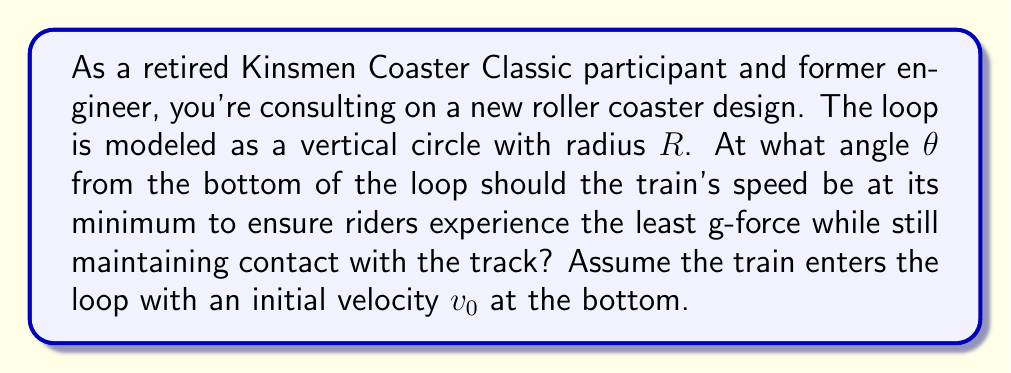Solve this math problem. Let's approach this step-by-step:

1) First, we need to understand the forces acting on the riders. At any point in the loop, there are two main forces:
   - Centripetal force: $F_c = \frac{mv^2}{R}$
   - Gravitational force: $mg$

2) For the riders to maintain contact with the track, the centripetal force must be greater than or equal to the component of gravity perpendicular to the track:

   $$\frac{mv^2}{R} \geq mg\cos\theta$$

3) The velocity at any point in the loop can be found using conservation of energy:

   $$\frac{1}{2}mv_0^2 = \frac{1}{2}mv^2 + mgR(1-\cos\theta)$$

   Solving for $v^2$:

   $$v^2 = v_0^2 - 2gR(1-\cos\theta)$$

4) Substituting this into the inequality from step 2:

   $$\frac{m(v_0^2 - 2gR(1-\cos\theta))}{R} \geq mg\cos\theta$$

5) Simplifying:

   $$\frac{v_0^2}{R} - \frac{2g(1-\cos\theta)}{1} \geq g\cos\theta$$

6) To minimize g-forces, we want to find the point where this inequality is just satisfied (i.e., when it's an equality):

   $$\frac{v_0^2}{R} - 2g + 2g\cos\theta = g\cos\theta$$

7) Solving for $\cos\theta$:

   $$\cos\theta = \frac{v_0^2}{3gR} - \frac{2}{3}$$

8) The minimum speed occurs at the top of the loop ($\theta = \pi$). For the train to complete the loop, we must have:

   $$v_0^2 \geq 5gR$$

9) Using this minimum initial velocity in our equation for $\cos\theta$:

   $$\cos\theta = \frac{5gR}{3gR} - \frac{2}{3} = 1 - \frac{2}{3} = \frac{1}{3}$$

10) Therefore, the angle $\theta$ is:

    $$\theta = \arccos(\frac{1}{3}) \approx 70.53°$$

This angle is measured from the bottom of the loop, so it's equivalent to 19.47° below the horizontal.
Answer: The optimal angle is $\theta = \arccos(\frac{1}{3}) \approx 70.53°$ from the bottom of the loop, or 19.47° below the horizontal. 